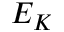Convert formula to latex. <formula><loc_0><loc_0><loc_500><loc_500>E _ { K }</formula> 